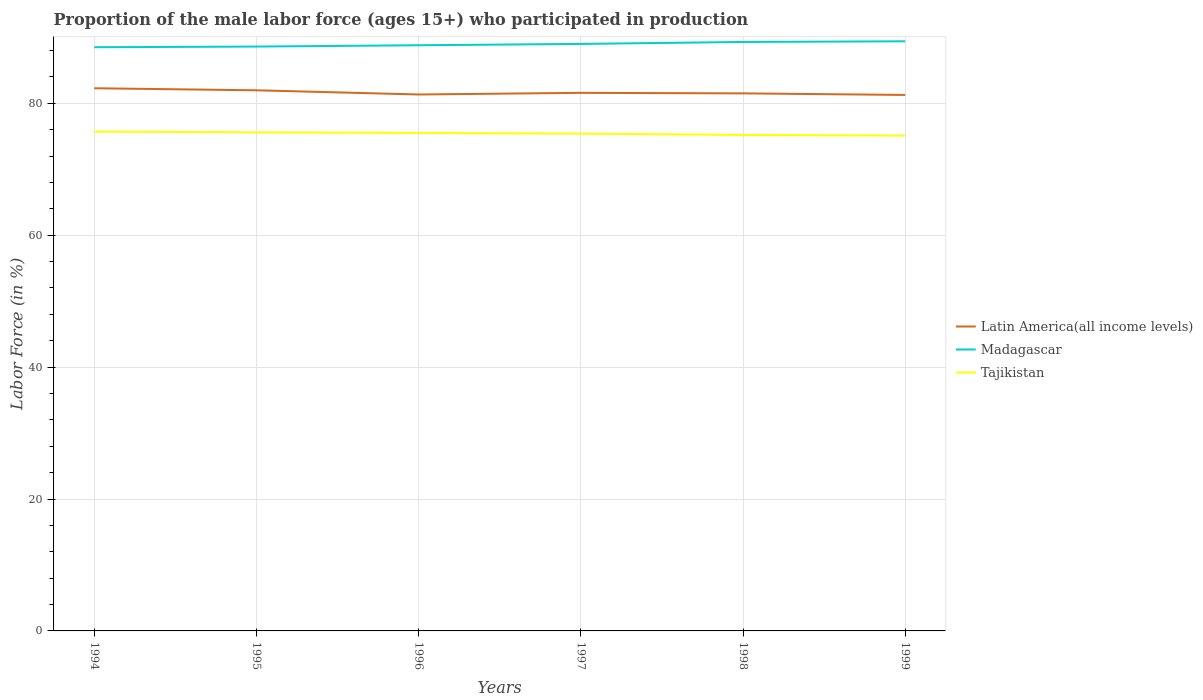Does the line corresponding to Tajikistan intersect with the line corresponding to Madagascar?
Offer a very short reply. No. Is the number of lines equal to the number of legend labels?
Give a very brief answer. Yes. Across all years, what is the maximum proportion of the male labor force who participated in production in Latin America(all income levels)?
Offer a very short reply. 81.27. In which year was the proportion of the male labor force who participated in production in Madagascar maximum?
Your response must be concise. 1994. What is the total proportion of the male labor force who participated in production in Tajikistan in the graph?
Provide a short and direct response. 0.3. What is the difference between the highest and the second highest proportion of the male labor force who participated in production in Tajikistan?
Provide a succinct answer. 0.6. Is the proportion of the male labor force who participated in production in Tajikistan strictly greater than the proportion of the male labor force who participated in production in Latin America(all income levels) over the years?
Provide a succinct answer. Yes. How many lines are there?
Offer a terse response. 3. What is the difference between two consecutive major ticks on the Y-axis?
Give a very brief answer. 20. Are the values on the major ticks of Y-axis written in scientific E-notation?
Provide a short and direct response. No. Does the graph contain grids?
Provide a succinct answer. Yes. How many legend labels are there?
Offer a terse response. 3. How are the legend labels stacked?
Keep it short and to the point. Vertical. What is the title of the graph?
Provide a short and direct response. Proportion of the male labor force (ages 15+) who participated in production. What is the label or title of the X-axis?
Your answer should be very brief. Years. What is the label or title of the Y-axis?
Your answer should be very brief. Labor Force (in %). What is the Labor Force (in %) in Latin America(all income levels) in 1994?
Give a very brief answer. 82.28. What is the Labor Force (in %) in Madagascar in 1994?
Provide a succinct answer. 88.5. What is the Labor Force (in %) in Tajikistan in 1994?
Keep it short and to the point. 75.7. What is the Labor Force (in %) in Latin America(all income levels) in 1995?
Your answer should be compact. 81.97. What is the Labor Force (in %) of Madagascar in 1995?
Offer a very short reply. 88.6. What is the Labor Force (in %) of Tajikistan in 1995?
Provide a short and direct response. 75.6. What is the Labor Force (in %) in Latin America(all income levels) in 1996?
Give a very brief answer. 81.34. What is the Labor Force (in %) in Madagascar in 1996?
Give a very brief answer. 88.8. What is the Labor Force (in %) of Tajikistan in 1996?
Your answer should be very brief. 75.5. What is the Labor Force (in %) in Latin America(all income levels) in 1997?
Offer a very short reply. 81.58. What is the Labor Force (in %) in Madagascar in 1997?
Offer a terse response. 89. What is the Labor Force (in %) in Tajikistan in 1997?
Your answer should be compact. 75.4. What is the Labor Force (in %) in Latin America(all income levels) in 1998?
Make the answer very short. 81.5. What is the Labor Force (in %) in Madagascar in 1998?
Offer a terse response. 89.3. What is the Labor Force (in %) in Tajikistan in 1998?
Give a very brief answer. 75.2. What is the Labor Force (in %) of Latin America(all income levels) in 1999?
Make the answer very short. 81.27. What is the Labor Force (in %) of Madagascar in 1999?
Offer a terse response. 89.4. What is the Labor Force (in %) in Tajikistan in 1999?
Offer a terse response. 75.1. Across all years, what is the maximum Labor Force (in %) of Latin America(all income levels)?
Keep it short and to the point. 82.28. Across all years, what is the maximum Labor Force (in %) in Madagascar?
Provide a short and direct response. 89.4. Across all years, what is the maximum Labor Force (in %) of Tajikistan?
Offer a terse response. 75.7. Across all years, what is the minimum Labor Force (in %) of Latin America(all income levels)?
Provide a succinct answer. 81.27. Across all years, what is the minimum Labor Force (in %) of Madagascar?
Offer a terse response. 88.5. Across all years, what is the minimum Labor Force (in %) in Tajikistan?
Provide a succinct answer. 75.1. What is the total Labor Force (in %) in Latin America(all income levels) in the graph?
Give a very brief answer. 489.94. What is the total Labor Force (in %) in Madagascar in the graph?
Keep it short and to the point. 533.6. What is the total Labor Force (in %) in Tajikistan in the graph?
Offer a terse response. 452.5. What is the difference between the Labor Force (in %) in Latin America(all income levels) in 1994 and that in 1995?
Make the answer very short. 0.31. What is the difference between the Labor Force (in %) in Tajikistan in 1994 and that in 1995?
Give a very brief answer. 0.1. What is the difference between the Labor Force (in %) in Latin America(all income levels) in 1994 and that in 1996?
Keep it short and to the point. 0.94. What is the difference between the Labor Force (in %) of Tajikistan in 1994 and that in 1996?
Make the answer very short. 0.2. What is the difference between the Labor Force (in %) in Latin America(all income levels) in 1994 and that in 1997?
Give a very brief answer. 0.7. What is the difference between the Labor Force (in %) in Tajikistan in 1994 and that in 1997?
Make the answer very short. 0.3. What is the difference between the Labor Force (in %) in Latin America(all income levels) in 1994 and that in 1998?
Ensure brevity in your answer.  0.78. What is the difference between the Labor Force (in %) of Madagascar in 1994 and that in 1998?
Keep it short and to the point. -0.8. What is the difference between the Labor Force (in %) in Latin America(all income levels) in 1994 and that in 1999?
Your answer should be very brief. 1.01. What is the difference between the Labor Force (in %) in Madagascar in 1994 and that in 1999?
Offer a terse response. -0.9. What is the difference between the Labor Force (in %) of Tajikistan in 1994 and that in 1999?
Ensure brevity in your answer.  0.6. What is the difference between the Labor Force (in %) in Latin America(all income levels) in 1995 and that in 1996?
Ensure brevity in your answer.  0.63. What is the difference between the Labor Force (in %) in Madagascar in 1995 and that in 1996?
Offer a terse response. -0.2. What is the difference between the Labor Force (in %) in Tajikistan in 1995 and that in 1996?
Make the answer very short. 0.1. What is the difference between the Labor Force (in %) in Latin America(all income levels) in 1995 and that in 1997?
Offer a very short reply. 0.39. What is the difference between the Labor Force (in %) of Latin America(all income levels) in 1995 and that in 1998?
Keep it short and to the point. 0.47. What is the difference between the Labor Force (in %) of Tajikistan in 1995 and that in 1998?
Your answer should be compact. 0.4. What is the difference between the Labor Force (in %) of Latin America(all income levels) in 1995 and that in 1999?
Your answer should be very brief. 0.7. What is the difference between the Labor Force (in %) of Latin America(all income levels) in 1996 and that in 1997?
Provide a succinct answer. -0.25. What is the difference between the Labor Force (in %) in Latin America(all income levels) in 1996 and that in 1998?
Ensure brevity in your answer.  -0.17. What is the difference between the Labor Force (in %) in Tajikistan in 1996 and that in 1998?
Your answer should be very brief. 0.3. What is the difference between the Labor Force (in %) in Latin America(all income levels) in 1996 and that in 1999?
Your response must be concise. 0.07. What is the difference between the Labor Force (in %) of Tajikistan in 1996 and that in 1999?
Ensure brevity in your answer.  0.4. What is the difference between the Labor Force (in %) of Latin America(all income levels) in 1997 and that in 1998?
Ensure brevity in your answer.  0.08. What is the difference between the Labor Force (in %) of Madagascar in 1997 and that in 1998?
Offer a very short reply. -0.3. What is the difference between the Labor Force (in %) in Tajikistan in 1997 and that in 1998?
Offer a very short reply. 0.2. What is the difference between the Labor Force (in %) in Latin America(all income levels) in 1997 and that in 1999?
Offer a terse response. 0.32. What is the difference between the Labor Force (in %) in Madagascar in 1997 and that in 1999?
Ensure brevity in your answer.  -0.4. What is the difference between the Labor Force (in %) in Tajikistan in 1997 and that in 1999?
Provide a short and direct response. 0.3. What is the difference between the Labor Force (in %) of Latin America(all income levels) in 1998 and that in 1999?
Provide a short and direct response. 0.24. What is the difference between the Labor Force (in %) of Latin America(all income levels) in 1994 and the Labor Force (in %) of Madagascar in 1995?
Keep it short and to the point. -6.32. What is the difference between the Labor Force (in %) of Latin America(all income levels) in 1994 and the Labor Force (in %) of Tajikistan in 1995?
Provide a short and direct response. 6.68. What is the difference between the Labor Force (in %) of Madagascar in 1994 and the Labor Force (in %) of Tajikistan in 1995?
Keep it short and to the point. 12.9. What is the difference between the Labor Force (in %) in Latin America(all income levels) in 1994 and the Labor Force (in %) in Madagascar in 1996?
Your answer should be very brief. -6.52. What is the difference between the Labor Force (in %) in Latin America(all income levels) in 1994 and the Labor Force (in %) in Tajikistan in 1996?
Ensure brevity in your answer.  6.78. What is the difference between the Labor Force (in %) in Madagascar in 1994 and the Labor Force (in %) in Tajikistan in 1996?
Ensure brevity in your answer.  13. What is the difference between the Labor Force (in %) of Latin America(all income levels) in 1994 and the Labor Force (in %) of Madagascar in 1997?
Provide a short and direct response. -6.72. What is the difference between the Labor Force (in %) in Latin America(all income levels) in 1994 and the Labor Force (in %) in Tajikistan in 1997?
Give a very brief answer. 6.88. What is the difference between the Labor Force (in %) of Madagascar in 1994 and the Labor Force (in %) of Tajikistan in 1997?
Your response must be concise. 13.1. What is the difference between the Labor Force (in %) in Latin America(all income levels) in 1994 and the Labor Force (in %) in Madagascar in 1998?
Offer a terse response. -7.02. What is the difference between the Labor Force (in %) of Latin America(all income levels) in 1994 and the Labor Force (in %) of Tajikistan in 1998?
Your answer should be very brief. 7.08. What is the difference between the Labor Force (in %) of Madagascar in 1994 and the Labor Force (in %) of Tajikistan in 1998?
Keep it short and to the point. 13.3. What is the difference between the Labor Force (in %) in Latin America(all income levels) in 1994 and the Labor Force (in %) in Madagascar in 1999?
Your response must be concise. -7.12. What is the difference between the Labor Force (in %) of Latin America(all income levels) in 1994 and the Labor Force (in %) of Tajikistan in 1999?
Ensure brevity in your answer.  7.18. What is the difference between the Labor Force (in %) of Latin America(all income levels) in 1995 and the Labor Force (in %) of Madagascar in 1996?
Make the answer very short. -6.83. What is the difference between the Labor Force (in %) in Latin America(all income levels) in 1995 and the Labor Force (in %) in Tajikistan in 1996?
Ensure brevity in your answer.  6.47. What is the difference between the Labor Force (in %) of Latin America(all income levels) in 1995 and the Labor Force (in %) of Madagascar in 1997?
Keep it short and to the point. -7.03. What is the difference between the Labor Force (in %) of Latin America(all income levels) in 1995 and the Labor Force (in %) of Tajikistan in 1997?
Offer a very short reply. 6.57. What is the difference between the Labor Force (in %) in Madagascar in 1995 and the Labor Force (in %) in Tajikistan in 1997?
Offer a terse response. 13.2. What is the difference between the Labor Force (in %) in Latin America(all income levels) in 1995 and the Labor Force (in %) in Madagascar in 1998?
Your answer should be compact. -7.33. What is the difference between the Labor Force (in %) of Latin America(all income levels) in 1995 and the Labor Force (in %) of Tajikistan in 1998?
Provide a short and direct response. 6.77. What is the difference between the Labor Force (in %) of Madagascar in 1995 and the Labor Force (in %) of Tajikistan in 1998?
Offer a very short reply. 13.4. What is the difference between the Labor Force (in %) of Latin America(all income levels) in 1995 and the Labor Force (in %) of Madagascar in 1999?
Provide a succinct answer. -7.43. What is the difference between the Labor Force (in %) of Latin America(all income levels) in 1995 and the Labor Force (in %) of Tajikistan in 1999?
Offer a very short reply. 6.87. What is the difference between the Labor Force (in %) in Madagascar in 1995 and the Labor Force (in %) in Tajikistan in 1999?
Keep it short and to the point. 13.5. What is the difference between the Labor Force (in %) of Latin America(all income levels) in 1996 and the Labor Force (in %) of Madagascar in 1997?
Offer a very short reply. -7.66. What is the difference between the Labor Force (in %) in Latin America(all income levels) in 1996 and the Labor Force (in %) in Tajikistan in 1997?
Offer a very short reply. 5.94. What is the difference between the Labor Force (in %) in Latin America(all income levels) in 1996 and the Labor Force (in %) in Madagascar in 1998?
Your answer should be compact. -7.96. What is the difference between the Labor Force (in %) of Latin America(all income levels) in 1996 and the Labor Force (in %) of Tajikistan in 1998?
Ensure brevity in your answer.  6.14. What is the difference between the Labor Force (in %) in Latin America(all income levels) in 1996 and the Labor Force (in %) in Madagascar in 1999?
Ensure brevity in your answer.  -8.06. What is the difference between the Labor Force (in %) of Latin America(all income levels) in 1996 and the Labor Force (in %) of Tajikistan in 1999?
Provide a short and direct response. 6.24. What is the difference between the Labor Force (in %) in Latin America(all income levels) in 1997 and the Labor Force (in %) in Madagascar in 1998?
Make the answer very short. -7.72. What is the difference between the Labor Force (in %) in Latin America(all income levels) in 1997 and the Labor Force (in %) in Tajikistan in 1998?
Give a very brief answer. 6.38. What is the difference between the Labor Force (in %) in Latin America(all income levels) in 1997 and the Labor Force (in %) in Madagascar in 1999?
Provide a short and direct response. -7.82. What is the difference between the Labor Force (in %) in Latin America(all income levels) in 1997 and the Labor Force (in %) in Tajikistan in 1999?
Ensure brevity in your answer.  6.48. What is the difference between the Labor Force (in %) in Madagascar in 1997 and the Labor Force (in %) in Tajikistan in 1999?
Keep it short and to the point. 13.9. What is the difference between the Labor Force (in %) in Latin America(all income levels) in 1998 and the Labor Force (in %) in Madagascar in 1999?
Your answer should be compact. -7.9. What is the difference between the Labor Force (in %) in Latin America(all income levels) in 1998 and the Labor Force (in %) in Tajikistan in 1999?
Your answer should be compact. 6.4. What is the average Labor Force (in %) in Latin America(all income levels) per year?
Provide a succinct answer. 81.66. What is the average Labor Force (in %) in Madagascar per year?
Keep it short and to the point. 88.93. What is the average Labor Force (in %) in Tajikistan per year?
Ensure brevity in your answer.  75.42. In the year 1994, what is the difference between the Labor Force (in %) of Latin America(all income levels) and Labor Force (in %) of Madagascar?
Offer a very short reply. -6.22. In the year 1994, what is the difference between the Labor Force (in %) of Latin America(all income levels) and Labor Force (in %) of Tajikistan?
Your answer should be very brief. 6.58. In the year 1995, what is the difference between the Labor Force (in %) of Latin America(all income levels) and Labor Force (in %) of Madagascar?
Make the answer very short. -6.63. In the year 1995, what is the difference between the Labor Force (in %) in Latin America(all income levels) and Labor Force (in %) in Tajikistan?
Give a very brief answer. 6.37. In the year 1996, what is the difference between the Labor Force (in %) of Latin America(all income levels) and Labor Force (in %) of Madagascar?
Your answer should be compact. -7.46. In the year 1996, what is the difference between the Labor Force (in %) in Latin America(all income levels) and Labor Force (in %) in Tajikistan?
Make the answer very short. 5.84. In the year 1996, what is the difference between the Labor Force (in %) in Madagascar and Labor Force (in %) in Tajikistan?
Your answer should be compact. 13.3. In the year 1997, what is the difference between the Labor Force (in %) in Latin America(all income levels) and Labor Force (in %) in Madagascar?
Give a very brief answer. -7.42. In the year 1997, what is the difference between the Labor Force (in %) in Latin America(all income levels) and Labor Force (in %) in Tajikistan?
Ensure brevity in your answer.  6.18. In the year 1998, what is the difference between the Labor Force (in %) in Latin America(all income levels) and Labor Force (in %) in Madagascar?
Provide a succinct answer. -7.8. In the year 1998, what is the difference between the Labor Force (in %) in Latin America(all income levels) and Labor Force (in %) in Tajikistan?
Provide a succinct answer. 6.3. In the year 1998, what is the difference between the Labor Force (in %) in Madagascar and Labor Force (in %) in Tajikistan?
Provide a short and direct response. 14.1. In the year 1999, what is the difference between the Labor Force (in %) in Latin America(all income levels) and Labor Force (in %) in Madagascar?
Your answer should be compact. -8.13. In the year 1999, what is the difference between the Labor Force (in %) of Latin America(all income levels) and Labor Force (in %) of Tajikistan?
Your answer should be very brief. 6.17. In the year 1999, what is the difference between the Labor Force (in %) in Madagascar and Labor Force (in %) in Tajikistan?
Your answer should be compact. 14.3. What is the ratio of the Labor Force (in %) of Latin America(all income levels) in 1994 to that in 1995?
Provide a succinct answer. 1. What is the ratio of the Labor Force (in %) in Tajikistan in 1994 to that in 1995?
Your answer should be compact. 1. What is the ratio of the Labor Force (in %) of Latin America(all income levels) in 1994 to that in 1996?
Your answer should be very brief. 1.01. What is the ratio of the Labor Force (in %) of Tajikistan in 1994 to that in 1996?
Offer a very short reply. 1. What is the ratio of the Labor Force (in %) of Latin America(all income levels) in 1994 to that in 1997?
Make the answer very short. 1.01. What is the ratio of the Labor Force (in %) in Latin America(all income levels) in 1994 to that in 1998?
Provide a short and direct response. 1.01. What is the ratio of the Labor Force (in %) in Tajikistan in 1994 to that in 1998?
Provide a short and direct response. 1.01. What is the ratio of the Labor Force (in %) in Latin America(all income levels) in 1994 to that in 1999?
Offer a terse response. 1.01. What is the ratio of the Labor Force (in %) of Latin America(all income levels) in 1995 to that in 1996?
Offer a very short reply. 1.01. What is the ratio of the Labor Force (in %) of Madagascar in 1995 to that in 1996?
Your answer should be compact. 1. What is the ratio of the Labor Force (in %) in Madagascar in 1995 to that in 1997?
Provide a short and direct response. 1. What is the ratio of the Labor Force (in %) in Madagascar in 1995 to that in 1998?
Make the answer very short. 0.99. What is the ratio of the Labor Force (in %) of Tajikistan in 1995 to that in 1998?
Your answer should be very brief. 1.01. What is the ratio of the Labor Force (in %) of Latin America(all income levels) in 1995 to that in 1999?
Make the answer very short. 1.01. What is the ratio of the Labor Force (in %) in Madagascar in 1995 to that in 1999?
Provide a short and direct response. 0.99. What is the ratio of the Labor Force (in %) of Tajikistan in 1995 to that in 1999?
Offer a very short reply. 1.01. What is the ratio of the Labor Force (in %) in Latin America(all income levels) in 1996 to that in 1997?
Offer a very short reply. 1. What is the ratio of the Labor Force (in %) in Tajikistan in 1996 to that in 1997?
Ensure brevity in your answer.  1. What is the ratio of the Labor Force (in %) in Madagascar in 1996 to that in 1998?
Your answer should be compact. 0.99. What is the ratio of the Labor Force (in %) in Tajikistan in 1996 to that in 1999?
Your answer should be very brief. 1.01. What is the ratio of the Labor Force (in %) in Latin America(all income levels) in 1997 to that in 1998?
Offer a very short reply. 1. What is the ratio of the Labor Force (in %) of Madagascar in 1997 to that in 1998?
Your answer should be very brief. 1. What is the ratio of the Labor Force (in %) of Tajikistan in 1997 to that in 1998?
Offer a terse response. 1. What is the ratio of the Labor Force (in %) in Latin America(all income levels) in 1998 to that in 1999?
Your answer should be very brief. 1. What is the ratio of the Labor Force (in %) of Tajikistan in 1998 to that in 1999?
Provide a short and direct response. 1. What is the difference between the highest and the second highest Labor Force (in %) in Latin America(all income levels)?
Give a very brief answer. 0.31. What is the difference between the highest and the lowest Labor Force (in %) of Latin America(all income levels)?
Your response must be concise. 1.01. What is the difference between the highest and the lowest Labor Force (in %) of Madagascar?
Provide a succinct answer. 0.9. 